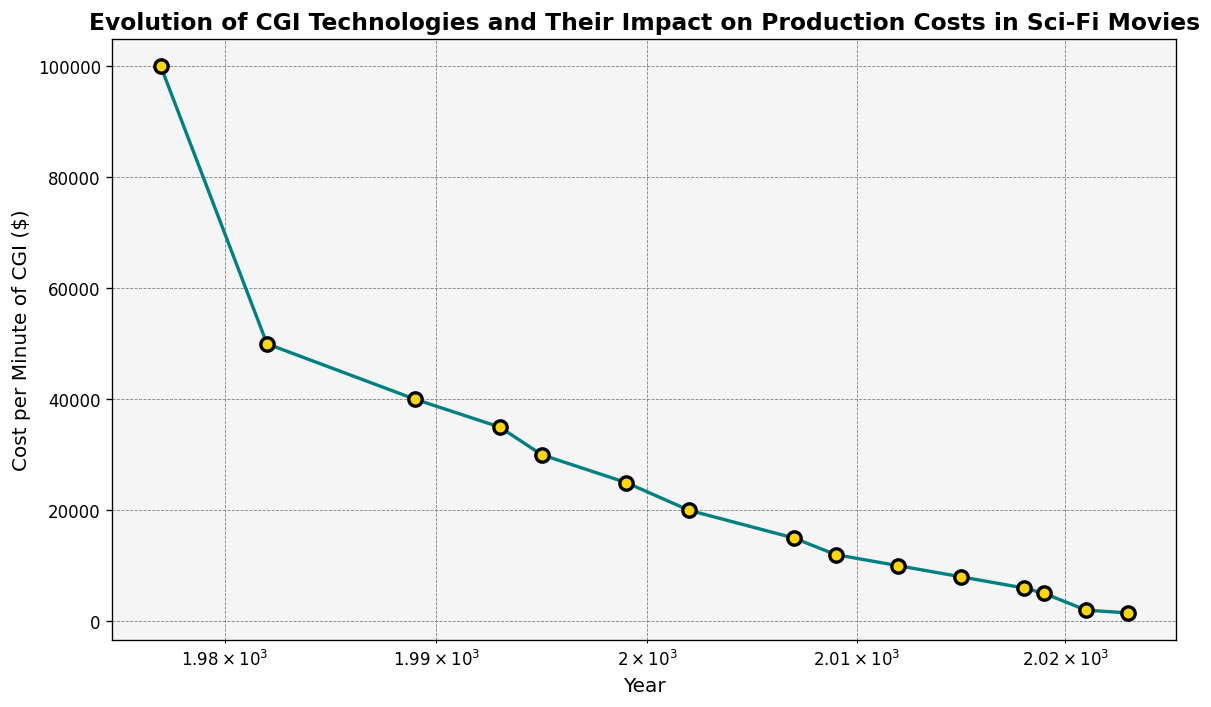What's the general trend in the cost per minute of CGI from 1977 to 2023? The overall trend shows a decrease in the cost per minute of CGI. As time progresses from 1977 to 2023, the costs are declining consistently.
Answer: Decreasing Which year shows the steepest drop in CGI costs compared to its previous year? Comparing each pair of consecutive years, 2021 to 2023 shows the steepest drop from $2000 to $1500. The decline is $500, which is the largest drop between any two consecutive years.
Answer: 2023 How does the cost per minute of CGI in 1995 compare to that in 1982? In 1995, the cost per minute of CGI is $30,000, while in 1982, it is $50,000. Since $30,000 is less than $50,000, the cost in 1995 is lower.
Answer: Lower What is the average cost per minute of CGI for the years 2015, 2018, and 2021? The costs for 2015, 2018, and 2021 are $8,000, $6,000, and $2,000 respectively. Summing these values, we get $16,000. Dividing by 3 (number of years), the average is $16,000 / 3 = $5,333.33.
Answer: $5,333.33 When did the cost per minute of CGI first drop below the $10,000 mark? The cost per minute of CGI first drops below $10,000 in 2015, where the cost is $8,000.
Answer: 2015 Compare the cost per minute of CGI between 1995 and 2009. Which year had lower costs and by how much? In 1995, the cost per minute is $30,000. In 2009, it is $12,000. The difference is $30,000 - $12,000 = $18,000. Therefore, 2009 had lower costs by $18,000.
Answer: 2009, by $18,000 What is the percentage decrease in CGI costs from 1977 to 2023? The cost in 1977 is $100,000, and in 2023 it is $1,500. The decrease is calculated as ($100,000 - $1,500) / $100,000 * 100 = 98.5%.
Answer: 98.5% How many years after 1999 did the cost per minute of CGI fall below $10,000? The cost per minute of CGI fell below $10,000 in 2015. The number of years after 1999 is 2015 - 1999 = 16 years.
Answer: 16 years What's the percentage decrease in CGI costs from 1999 to 2012? The cost in 1999 is $25,000, and in 2012 it is $10,000. The percentage decrease is ($25,000 - $10,000) / $25,000 * 100 = 60%.
Answer: 60% 